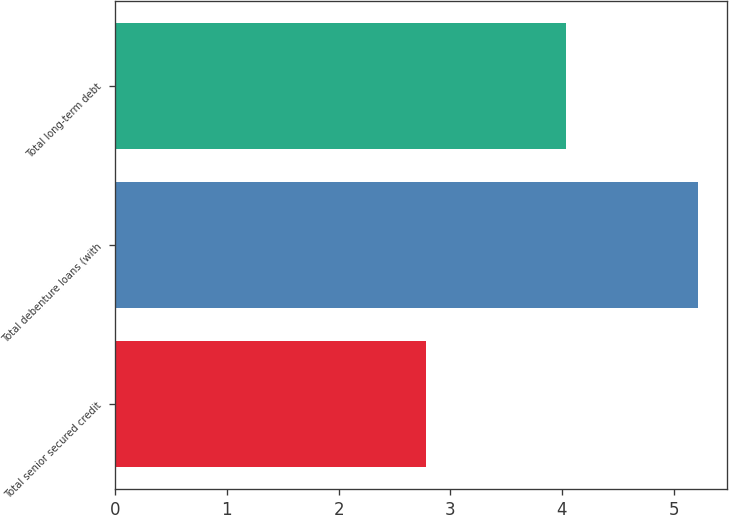Convert chart. <chart><loc_0><loc_0><loc_500><loc_500><bar_chart><fcel>Total senior secured credit<fcel>Total debenture loans (with<fcel>Total long-term debt<nl><fcel>2.78<fcel>5.22<fcel>4.04<nl></chart> 